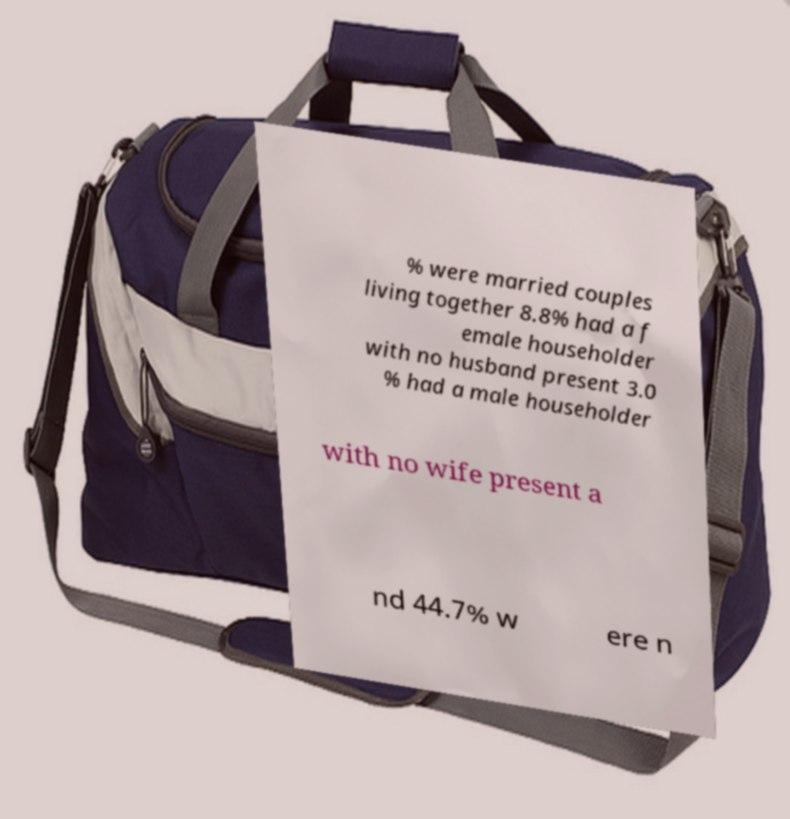What messages or text are displayed in this image? I need them in a readable, typed format. % were married couples living together 8.8% had a f emale householder with no husband present 3.0 % had a male householder with no wife present a nd 44.7% w ere n 